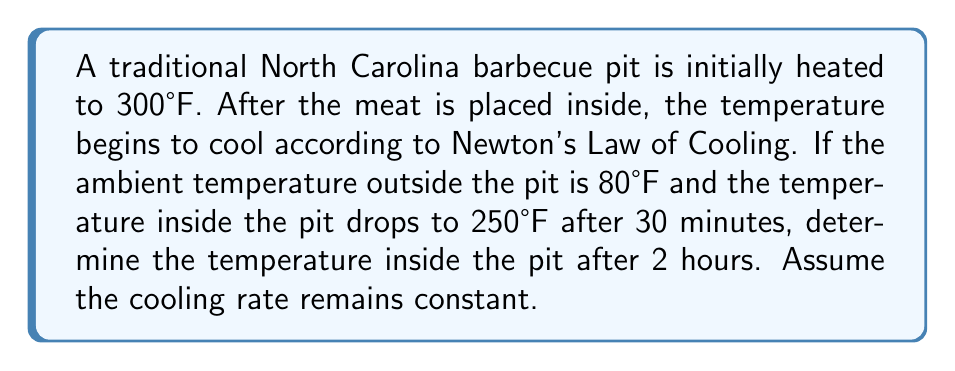Teach me how to tackle this problem. Let's approach this step-by-step using Newton's Law of Cooling:

1) The general form of Newton's Law of Cooling is:

   $$T(t) = T_s + (T_0 - T_s)e^{-kt}$$

   Where:
   $T(t)$ is the temperature at time $t$
   $T_s$ is the surrounding temperature
   $T_0$ is the initial temperature
   $k$ is the cooling constant

2) We know:
   $T_s = 80°F$ (ambient temperature)
   $T_0 = 300°F$ (initial pit temperature)
   After 30 minutes (0.5 hours), $T(0.5) = 250°F$

3) Let's substitute these values into the equation:

   $$250 = 80 + (300 - 80)e^{-k(0.5)}$$

4) Simplify:
   $$170 = 220e^{-0.5k}$$

5) Divide both sides by 220:
   $$\frac{17}{22} = e^{-0.5k}$$

6) Take natural log of both sides:
   $$\ln(\frac{17}{22}) = -0.5k$$

7) Solve for $k$:
   $$k = -2\ln(\frac{17}{22}) \approx 0.5108$$

8) Now that we have $k$, we can find the temperature after 2 hours by substituting into our original equation:

   $$T(2) = 80 + (300 - 80)e^{-0.5108(2)}$$

9) Simplify:
   $$T(2) = 80 + 220e^{-1.0216} \approx 159.8°F$$
Answer: 159.8°F 